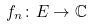Convert formula to latex. <formula><loc_0><loc_0><loc_500><loc_500>f _ { n } \colon E \to \mathbb { C }</formula> 